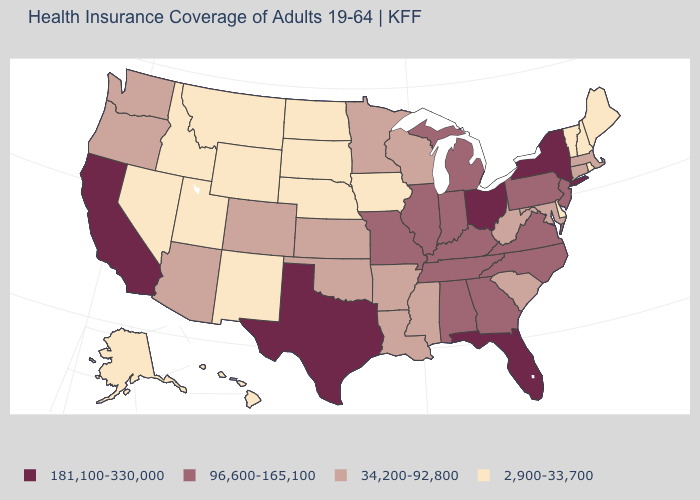Is the legend a continuous bar?
Keep it brief. No. Name the states that have a value in the range 2,900-33,700?
Be succinct. Alaska, Delaware, Hawaii, Idaho, Iowa, Maine, Montana, Nebraska, Nevada, New Hampshire, New Mexico, North Dakota, Rhode Island, South Dakota, Utah, Vermont, Wyoming. What is the value of Montana?
Be succinct. 2,900-33,700. What is the value of Wyoming?
Give a very brief answer. 2,900-33,700. What is the value of Delaware?
Concise answer only. 2,900-33,700. Which states have the lowest value in the MidWest?
Concise answer only. Iowa, Nebraska, North Dakota, South Dakota. Which states have the lowest value in the USA?
Give a very brief answer. Alaska, Delaware, Hawaii, Idaho, Iowa, Maine, Montana, Nebraska, Nevada, New Hampshire, New Mexico, North Dakota, Rhode Island, South Dakota, Utah, Vermont, Wyoming. Does Ohio have the highest value in the MidWest?
Write a very short answer. Yes. Which states have the lowest value in the USA?
Answer briefly. Alaska, Delaware, Hawaii, Idaho, Iowa, Maine, Montana, Nebraska, Nevada, New Hampshire, New Mexico, North Dakota, Rhode Island, South Dakota, Utah, Vermont, Wyoming. Name the states that have a value in the range 2,900-33,700?
Give a very brief answer. Alaska, Delaware, Hawaii, Idaho, Iowa, Maine, Montana, Nebraska, Nevada, New Hampshire, New Mexico, North Dakota, Rhode Island, South Dakota, Utah, Vermont, Wyoming. Name the states that have a value in the range 96,600-165,100?
Quick response, please. Alabama, Georgia, Illinois, Indiana, Kentucky, Michigan, Missouri, New Jersey, North Carolina, Pennsylvania, Tennessee, Virginia. Does New Mexico have the same value as Mississippi?
Short answer required. No. Does Virginia have a higher value than Florida?
Be succinct. No. What is the value of Montana?
Keep it brief. 2,900-33,700. Does Utah have a lower value than Michigan?
Answer briefly. Yes. 